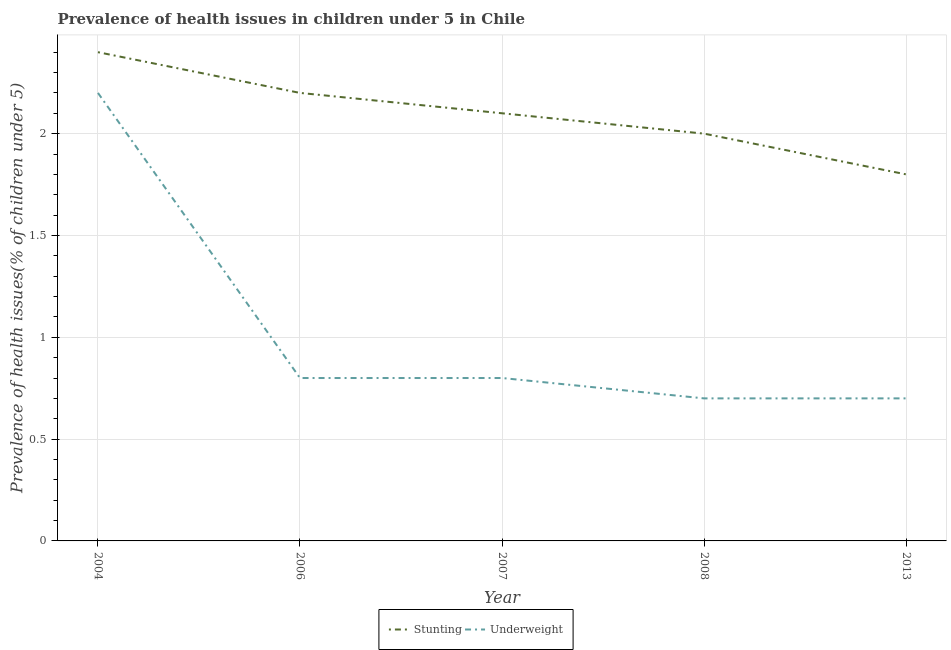Does the line corresponding to percentage of stunted children intersect with the line corresponding to percentage of underweight children?
Provide a succinct answer. No. Is the number of lines equal to the number of legend labels?
Keep it short and to the point. Yes. What is the percentage of underweight children in 2013?
Give a very brief answer. 0.7. Across all years, what is the maximum percentage of stunted children?
Your response must be concise. 2.4. Across all years, what is the minimum percentage of stunted children?
Your answer should be compact. 1.8. What is the difference between the percentage of stunted children in 2007 and that in 2013?
Your response must be concise. 0.3. What is the difference between the percentage of stunted children in 2004 and the percentage of underweight children in 2006?
Your response must be concise. 1.6. What is the average percentage of underweight children per year?
Offer a terse response. 1.04. In the year 2008, what is the difference between the percentage of underweight children and percentage of stunted children?
Offer a terse response. -1.3. In how many years, is the percentage of stunted children greater than 1.4 %?
Make the answer very short. 5. What is the ratio of the percentage of underweight children in 2007 to that in 2013?
Your answer should be very brief. 1.14. Is the percentage of stunted children in 2007 less than that in 2008?
Give a very brief answer. No. What is the difference between the highest and the second highest percentage of stunted children?
Make the answer very short. 0.2. What is the difference between the highest and the lowest percentage of underweight children?
Give a very brief answer. 1.5. Does the percentage of underweight children monotonically increase over the years?
Your answer should be very brief. No. Is the percentage of underweight children strictly greater than the percentage of stunted children over the years?
Offer a terse response. No. Where does the legend appear in the graph?
Offer a very short reply. Bottom center. How many legend labels are there?
Provide a succinct answer. 2. What is the title of the graph?
Give a very brief answer. Prevalence of health issues in children under 5 in Chile. What is the label or title of the Y-axis?
Provide a short and direct response. Prevalence of health issues(% of children under 5). What is the Prevalence of health issues(% of children under 5) in Stunting in 2004?
Keep it short and to the point. 2.4. What is the Prevalence of health issues(% of children under 5) of Underweight in 2004?
Your response must be concise. 2.2. What is the Prevalence of health issues(% of children under 5) of Stunting in 2006?
Provide a succinct answer. 2.2. What is the Prevalence of health issues(% of children under 5) of Underweight in 2006?
Make the answer very short. 0.8. What is the Prevalence of health issues(% of children under 5) in Stunting in 2007?
Your answer should be compact. 2.1. What is the Prevalence of health issues(% of children under 5) of Underweight in 2007?
Your answer should be very brief. 0.8. What is the Prevalence of health issues(% of children under 5) in Stunting in 2008?
Ensure brevity in your answer.  2. What is the Prevalence of health issues(% of children under 5) in Underweight in 2008?
Give a very brief answer. 0.7. What is the Prevalence of health issues(% of children under 5) of Stunting in 2013?
Your response must be concise. 1.8. What is the Prevalence of health issues(% of children under 5) of Underweight in 2013?
Make the answer very short. 0.7. Across all years, what is the maximum Prevalence of health issues(% of children under 5) of Stunting?
Your answer should be very brief. 2.4. Across all years, what is the maximum Prevalence of health issues(% of children under 5) of Underweight?
Ensure brevity in your answer.  2.2. Across all years, what is the minimum Prevalence of health issues(% of children under 5) in Stunting?
Provide a short and direct response. 1.8. Across all years, what is the minimum Prevalence of health issues(% of children under 5) of Underweight?
Your answer should be very brief. 0.7. What is the total Prevalence of health issues(% of children under 5) in Underweight in the graph?
Ensure brevity in your answer.  5.2. What is the difference between the Prevalence of health issues(% of children under 5) in Underweight in 2004 and that in 2006?
Offer a very short reply. 1.4. What is the difference between the Prevalence of health issues(% of children under 5) of Underweight in 2004 and that in 2008?
Your answer should be very brief. 1.5. What is the difference between the Prevalence of health issues(% of children under 5) of Stunting in 2004 and that in 2013?
Give a very brief answer. 0.6. What is the difference between the Prevalence of health issues(% of children under 5) in Underweight in 2004 and that in 2013?
Make the answer very short. 1.5. What is the difference between the Prevalence of health issues(% of children under 5) of Underweight in 2006 and that in 2007?
Offer a terse response. 0. What is the difference between the Prevalence of health issues(% of children under 5) in Stunting in 2006 and that in 2013?
Your response must be concise. 0.4. What is the difference between the Prevalence of health issues(% of children under 5) in Stunting in 2007 and that in 2008?
Provide a succinct answer. 0.1. What is the difference between the Prevalence of health issues(% of children under 5) in Underweight in 2007 and that in 2008?
Keep it short and to the point. 0.1. What is the difference between the Prevalence of health issues(% of children under 5) in Stunting in 2008 and that in 2013?
Make the answer very short. 0.2. What is the difference between the Prevalence of health issues(% of children under 5) of Stunting in 2004 and the Prevalence of health issues(% of children under 5) of Underweight in 2006?
Keep it short and to the point. 1.6. What is the difference between the Prevalence of health issues(% of children under 5) of Stunting in 2004 and the Prevalence of health issues(% of children under 5) of Underweight in 2007?
Your response must be concise. 1.6. What is the difference between the Prevalence of health issues(% of children under 5) in Stunting in 2004 and the Prevalence of health issues(% of children under 5) in Underweight in 2013?
Offer a terse response. 1.7. What is the difference between the Prevalence of health issues(% of children under 5) in Stunting in 2006 and the Prevalence of health issues(% of children under 5) in Underweight in 2007?
Give a very brief answer. 1.4. What is the difference between the Prevalence of health issues(% of children under 5) in Stunting in 2006 and the Prevalence of health issues(% of children under 5) in Underweight in 2008?
Ensure brevity in your answer.  1.5. What is the difference between the Prevalence of health issues(% of children under 5) in Stunting in 2006 and the Prevalence of health issues(% of children under 5) in Underweight in 2013?
Your response must be concise. 1.5. What is the difference between the Prevalence of health issues(% of children under 5) of Stunting in 2008 and the Prevalence of health issues(% of children under 5) of Underweight in 2013?
Provide a succinct answer. 1.3. What is the average Prevalence of health issues(% of children under 5) of Stunting per year?
Offer a terse response. 2.1. What is the average Prevalence of health issues(% of children under 5) in Underweight per year?
Your answer should be very brief. 1.04. In the year 2004, what is the difference between the Prevalence of health issues(% of children under 5) of Stunting and Prevalence of health issues(% of children under 5) of Underweight?
Offer a very short reply. 0.2. In the year 2006, what is the difference between the Prevalence of health issues(% of children under 5) of Stunting and Prevalence of health issues(% of children under 5) of Underweight?
Ensure brevity in your answer.  1.4. What is the ratio of the Prevalence of health issues(% of children under 5) of Stunting in 2004 to that in 2006?
Keep it short and to the point. 1.09. What is the ratio of the Prevalence of health issues(% of children under 5) of Underweight in 2004 to that in 2006?
Ensure brevity in your answer.  2.75. What is the ratio of the Prevalence of health issues(% of children under 5) of Underweight in 2004 to that in 2007?
Your answer should be very brief. 2.75. What is the ratio of the Prevalence of health issues(% of children under 5) of Stunting in 2004 to that in 2008?
Offer a very short reply. 1.2. What is the ratio of the Prevalence of health issues(% of children under 5) in Underweight in 2004 to that in 2008?
Keep it short and to the point. 3.14. What is the ratio of the Prevalence of health issues(% of children under 5) in Stunting in 2004 to that in 2013?
Provide a succinct answer. 1.33. What is the ratio of the Prevalence of health issues(% of children under 5) in Underweight in 2004 to that in 2013?
Offer a very short reply. 3.14. What is the ratio of the Prevalence of health issues(% of children under 5) of Stunting in 2006 to that in 2007?
Give a very brief answer. 1.05. What is the ratio of the Prevalence of health issues(% of children under 5) of Underweight in 2006 to that in 2007?
Give a very brief answer. 1. What is the ratio of the Prevalence of health issues(% of children under 5) of Stunting in 2006 to that in 2013?
Your response must be concise. 1.22. What is the ratio of the Prevalence of health issues(% of children under 5) in Stunting in 2007 to that in 2008?
Provide a succinct answer. 1.05. What is the ratio of the Prevalence of health issues(% of children under 5) of Stunting in 2007 to that in 2013?
Your answer should be compact. 1.17. What is the difference between the highest and the second highest Prevalence of health issues(% of children under 5) in Stunting?
Give a very brief answer. 0.2. 